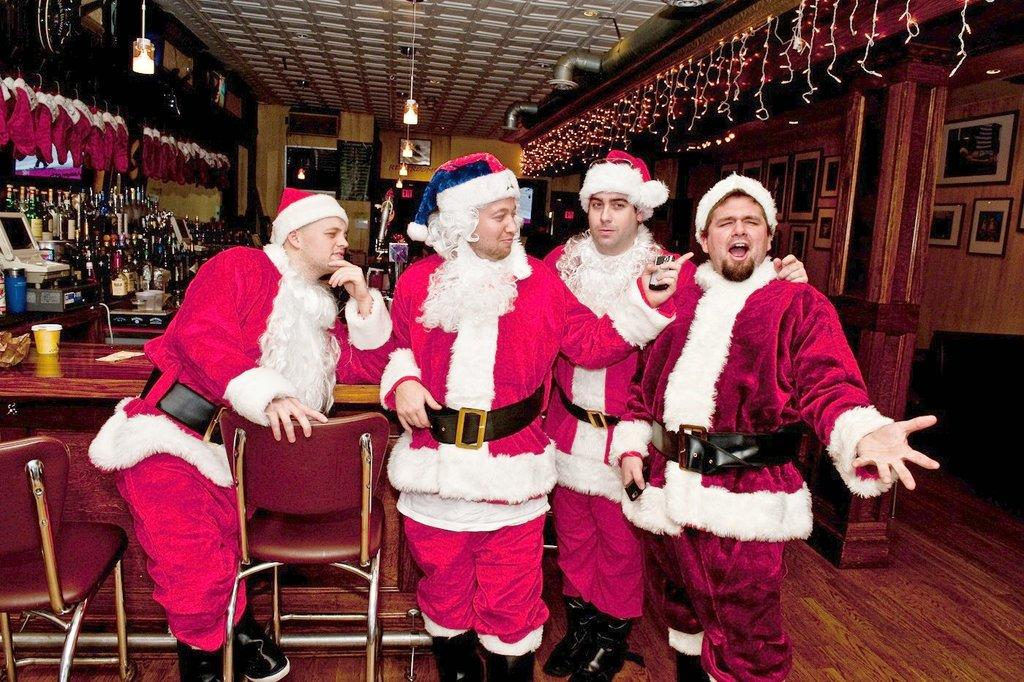How many people are present in the image? There are four people in the image. What are the people wearing? The people are wearing Santa dresses. What is the main piece of furniture in the image? There is a table in the image. What is unique about the bottles on the table? The bottles are decorated with lights. What color is the crayon used to draw on the mask in the image? There is no crayon or mask present in the image. How is the bait arranged on the table in the image? There is no bait present in the image; it is a table with bottles decorated with lights. 